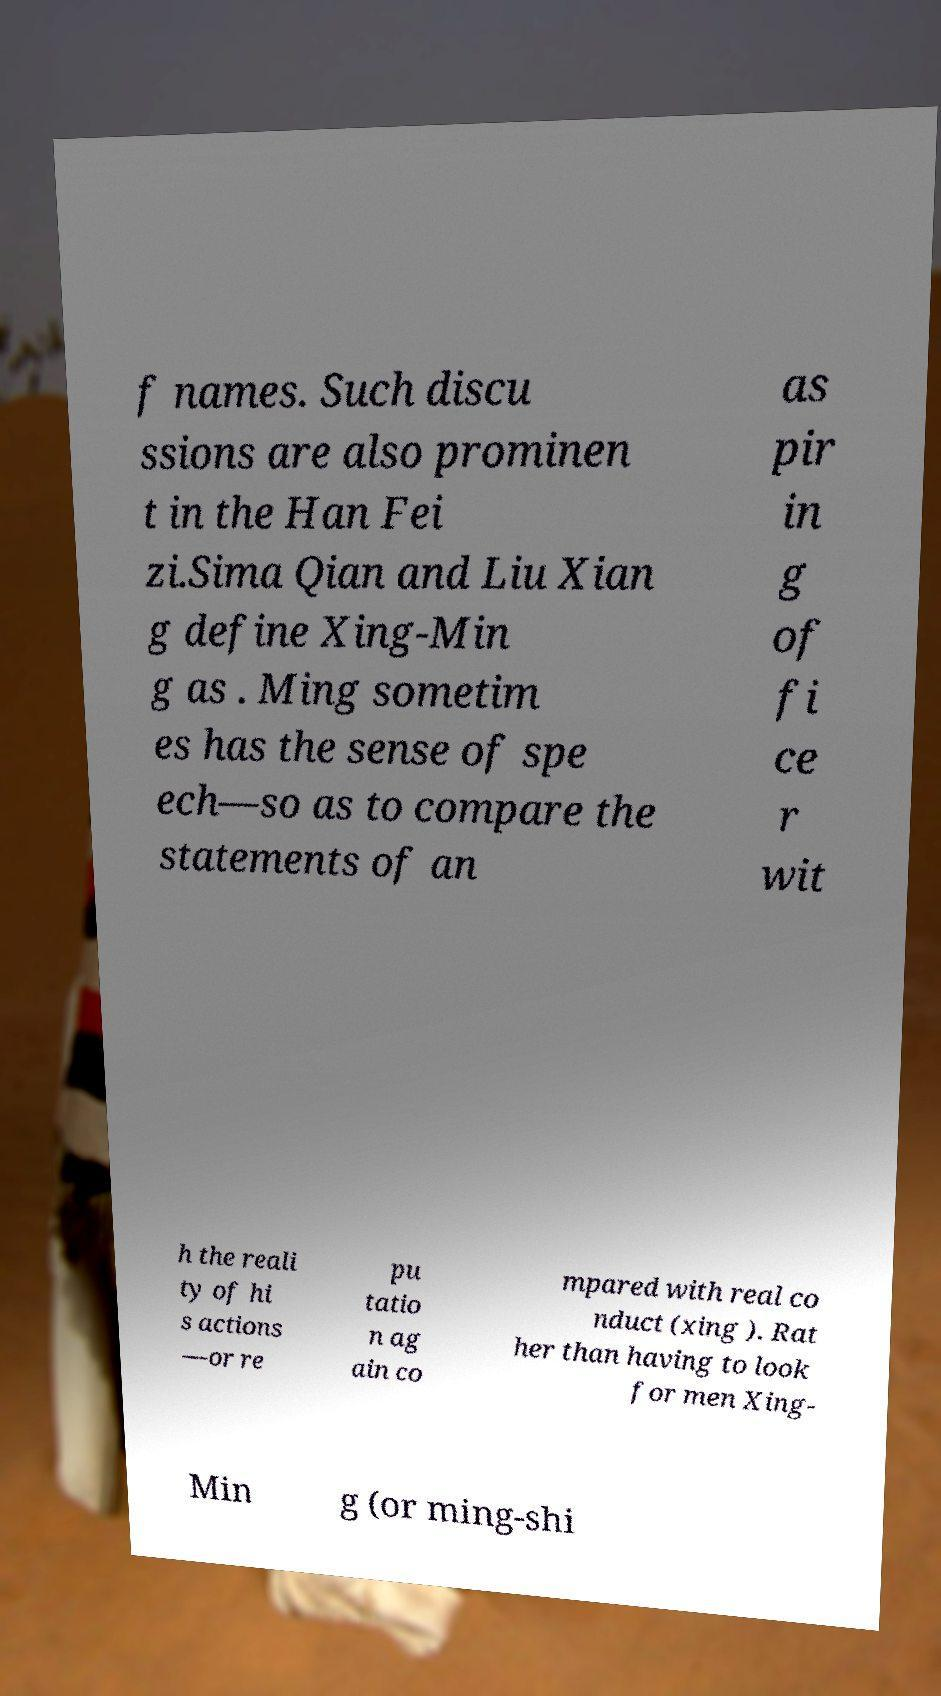Please read and relay the text visible in this image. What does it say? f names. Such discu ssions are also prominen t in the Han Fei zi.Sima Qian and Liu Xian g define Xing-Min g as . Ming sometim es has the sense of spe ech—so as to compare the statements of an as pir in g of fi ce r wit h the reali ty of hi s actions —or re pu tatio n ag ain co mpared with real co nduct (xing ). Rat her than having to look for men Xing- Min g (or ming-shi 